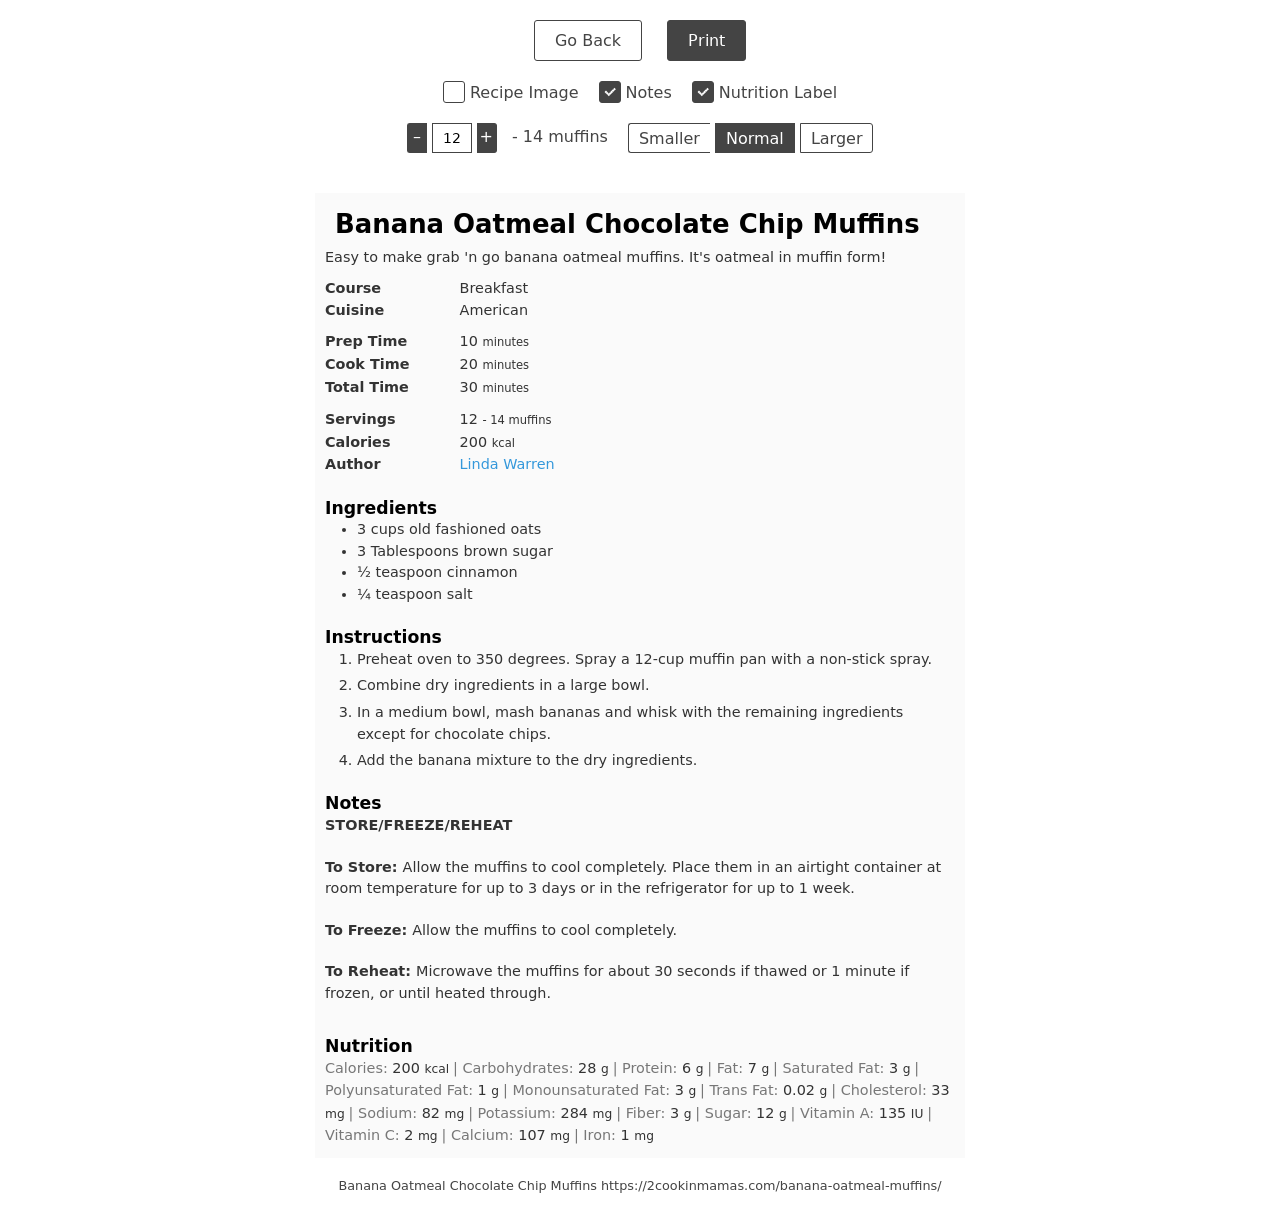Can you suggest more additions to spruce up the basic HTML template provided? Certainly! To enhance your basic HTML template, consider adding some interactive elements and stylish CSS. Here's an improved version of your template:

<!DOCTYPE html>
<html>
<head>
    <title>Your Website Title</title>
    <style>
        body { font-family: Arial, sans-serif; line-height: 1.6; }
        header { background: #f4f4f4; padding: 20px; text-align: center; }
        nav { background: #333; color: #fff; text-align: center; padding: 10px; }
        nav a { color: #fff; margin: 0 10px; text-decoration: none; }
        section { margin: 20px; }
    </style>
</head>
<body>
    <header>
        <h1>Welcome to My Website</h1>
    </header>
    <nav>
        <a href="#">Home</a>
        <a href="#">About</a>
        <a href="#">Services</a>
        <a href="#">Contact</a>
    </nav>
    <section>
        <p>This is an enhanced version of your basic site. It includes a header, navigation menu, and styled text.</p>
    </section>
</body>
</html>  How can I make the website responsive to different devices? To make your website responsive, you'll need to incorporate CSS media queries in your style section. These allow the page to adjust to different screen sizes. Here’s a basic example:

<style>
    body { font-family: Arial, sans-serif; line-height: 1.6; }
    header, nav, section { padding: 20px; }
    @media (max-width: 600px) {
        nav { text-align: left; }
        header, section { padding: 10px; }
    }
</style>

This modification ensures your website's layout adjusts to screen sizes smaller than 600 pixels, improving usability on mobile devices. 